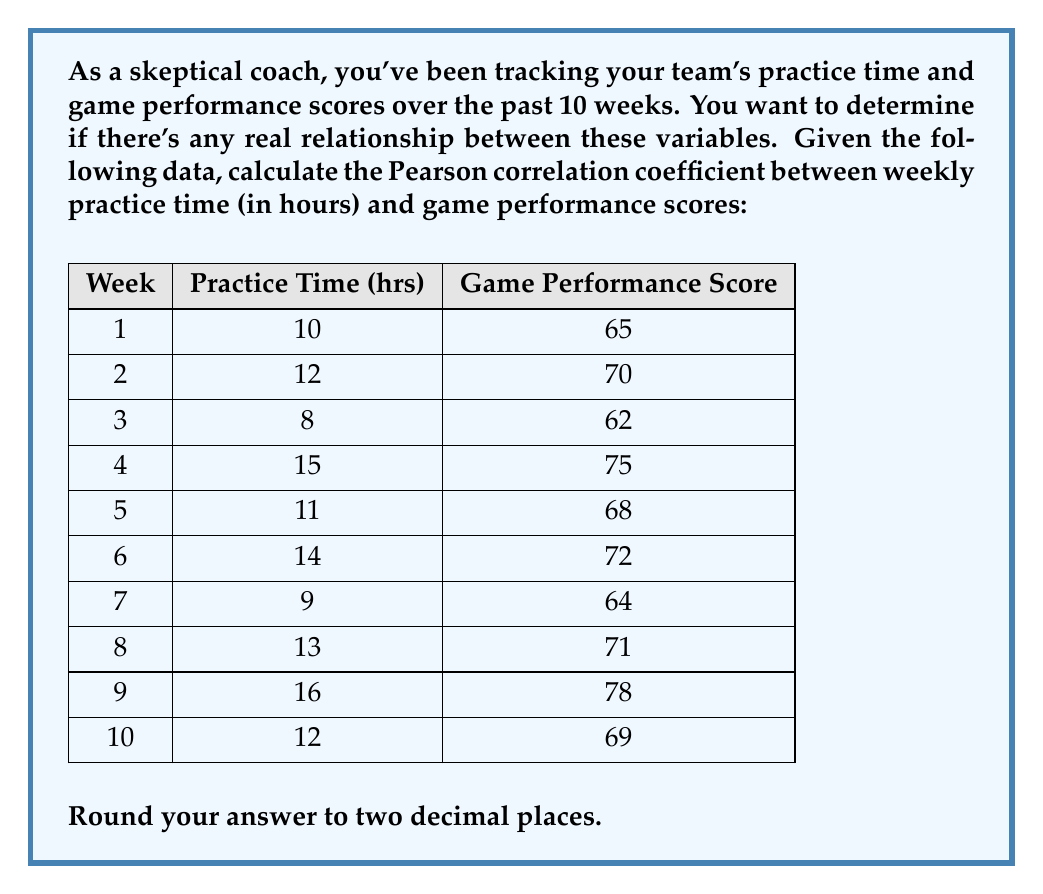Show me your answer to this math problem. To calculate the Pearson correlation coefficient, we'll use the formula:

$$ r = \frac{\sum_{i=1}^{n} (x_i - \bar{x})(y_i - \bar{y})}{\sqrt{\sum_{i=1}^{n} (x_i - \bar{x})^2 \sum_{i=1}^{n} (y_i - \bar{y})^2}} $$

Where:
$x_i$ = practice time for week i
$y_i$ = game performance score for week i
$\bar{x}$ = mean practice time
$\bar{y}$ = mean game performance score
$n$ = number of weeks (10)

Step 1: Calculate means
$\bar{x} = \frac{10 + 12 + 8 + 15 + 11 + 14 + 9 + 13 + 16 + 12}{10} = 12$ hours
$\bar{y} = \frac{65 + 70 + 62 + 75 + 68 + 72 + 64 + 71 + 78 + 69}{10} = 69.4$ points

Step 2: Calculate $(x_i - \bar{x})$, $(y_i - \bar{y})$, $(x_i - \bar{x})^2$, $(y_i - \bar{y})^2$, and $(x_i - \bar{x})(y_i - \bar{y})$ for each week.

Step 3: Sum up the calculated values:
$\sum (x_i - \bar{x})(y_i - \bar{y}) = 97.6$
$\sum (x_i - \bar{x})^2 = 70$
$\sum (y_i - \bar{y})^2 = 222.4$

Step 4: Apply the formula:

$$ r = \frac{97.6}{\sqrt{70 \times 222.4}} = \frac{97.6}{\sqrt{15568}} = \frac{97.6}{124.77} = 0.7822 $$

Step 5: Round to two decimal places: 0.78
Answer: 0.78 